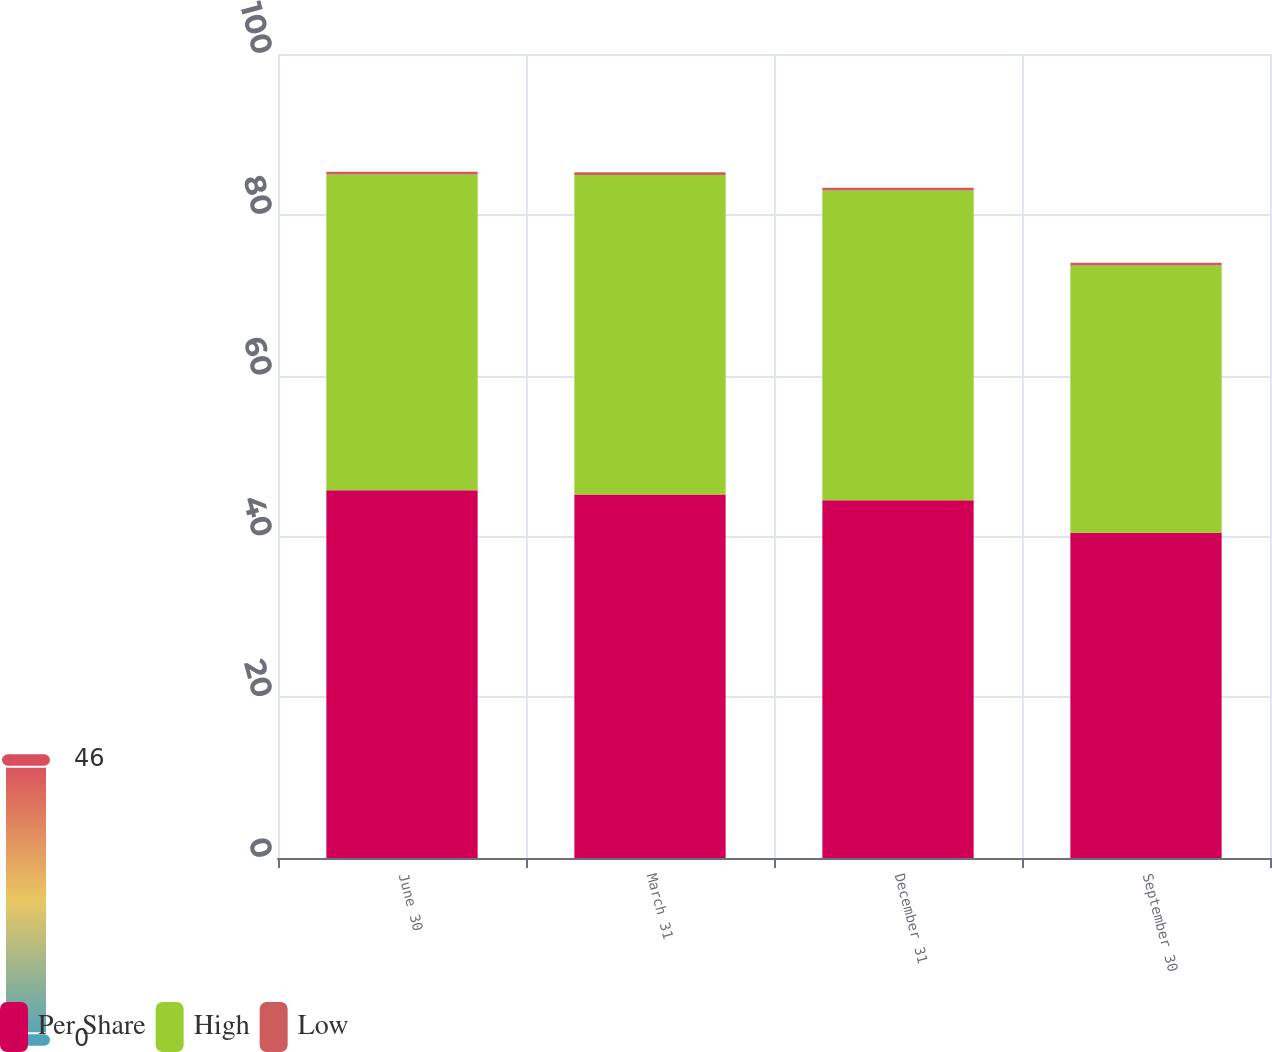Convert chart to OTSL. <chart><loc_0><loc_0><loc_500><loc_500><stacked_bar_chart><ecel><fcel>June 30<fcel>March 31<fcel>December 31<fcel>September 30<nl><fcel>Per Share<fcel>45.74<fcel>45.22<fcel>44.5<fcel>40.44<nl><fcel>High<fcel>39.27<fcel>39.72<fcel>38.51<fcel>33.26<nl><fcel>Low<fcel>0.34<fcel>0.34<fcel>0.34<fcel>0.33<nl></chart> 